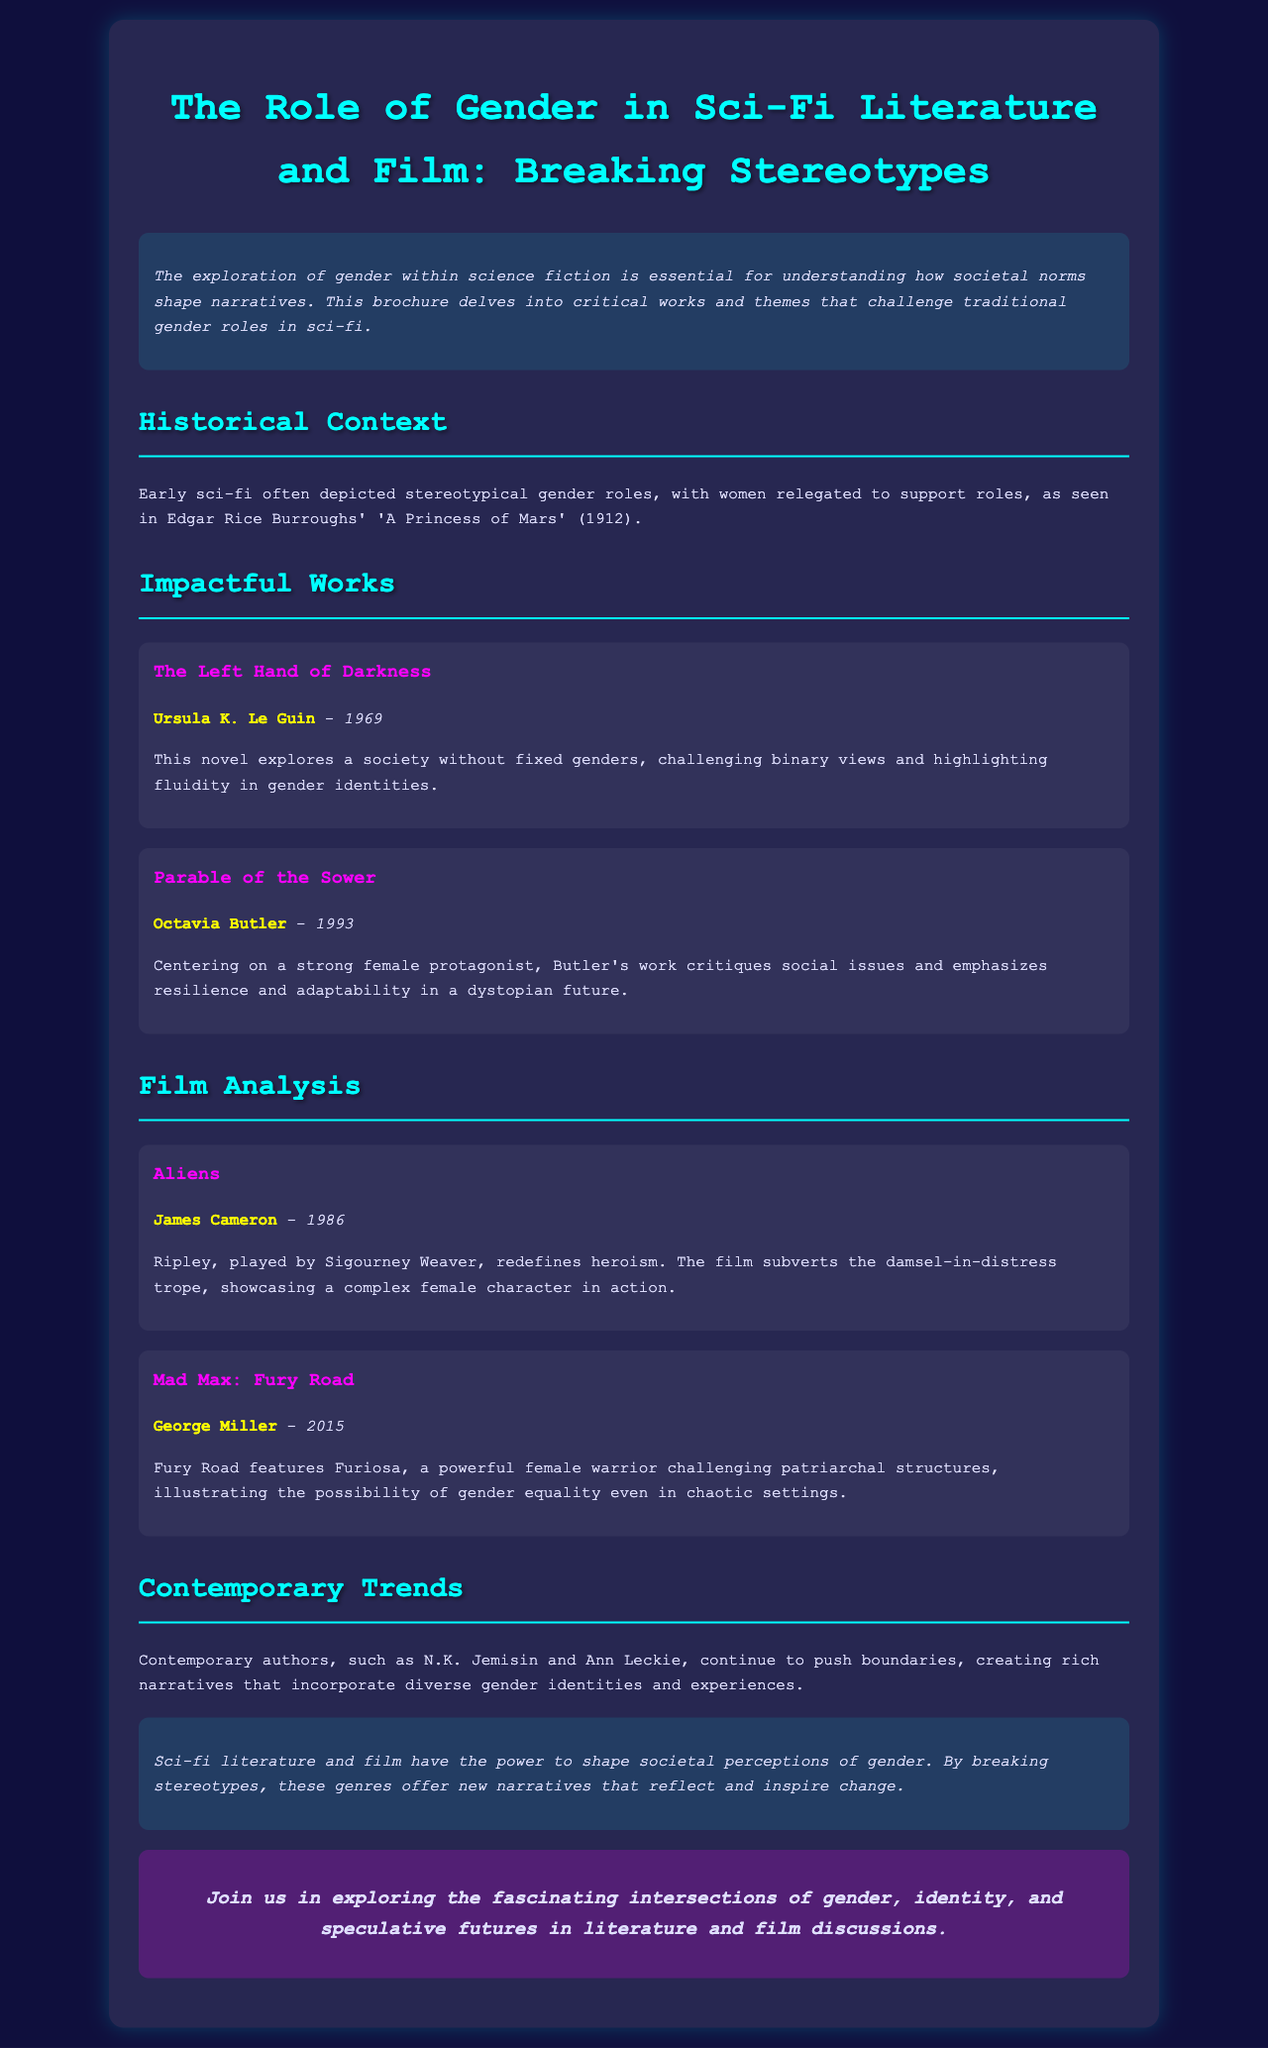what is the title of the brochure? The title of the brochure is presented at the top of the document, indicating the main topic discussed.
Answer: The Role of Gender in Sci-Fi Literature and Film: Breaking Stereotypes who is the author of "The Left Hand of Darkness"? The document lists the author alongside the title of the work in the Impactful Works section.
Answer: Ursula K. Le Guin what year was "Parable of the Sower" published? The publication year is indicated next to the title of the work in the brochure.
Answer: 1993 who directed the film "Aliens"? The director's name is mentioned in the Film Analysis section under the film title.
Answer: James Cameron which film features a character named Furiosa? The character is noted in the description of the film in the Film Analysis section.
Answer: Mad Max: Fury Road what theme is highlighted in "The Left Hand of Darkness"? The brochure explains the central theme associated with this impactful work in the Impactful Works section.
Answer: Fluidity in gender identities which contemporary authors are mentioned in the brochure? The document refers to contemporary authors in the Contemporary Trends section, providing examples.
Answer: N.K. Jemisin and Ann Leckie what genre is discussed in terms of gender narratives? The genre is identified in the title and introductory paragraph of the brochure.
Answer: Sci-fi what does the conclusion suggest about sci-fi's influence on society? The conclusion summarizes the overall message regarding the impact of the genre on societal perceptions.
Answer: Inspire change 